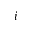<formula> <loc_0><loc_0><loc_500><loc_500>i</formula> 